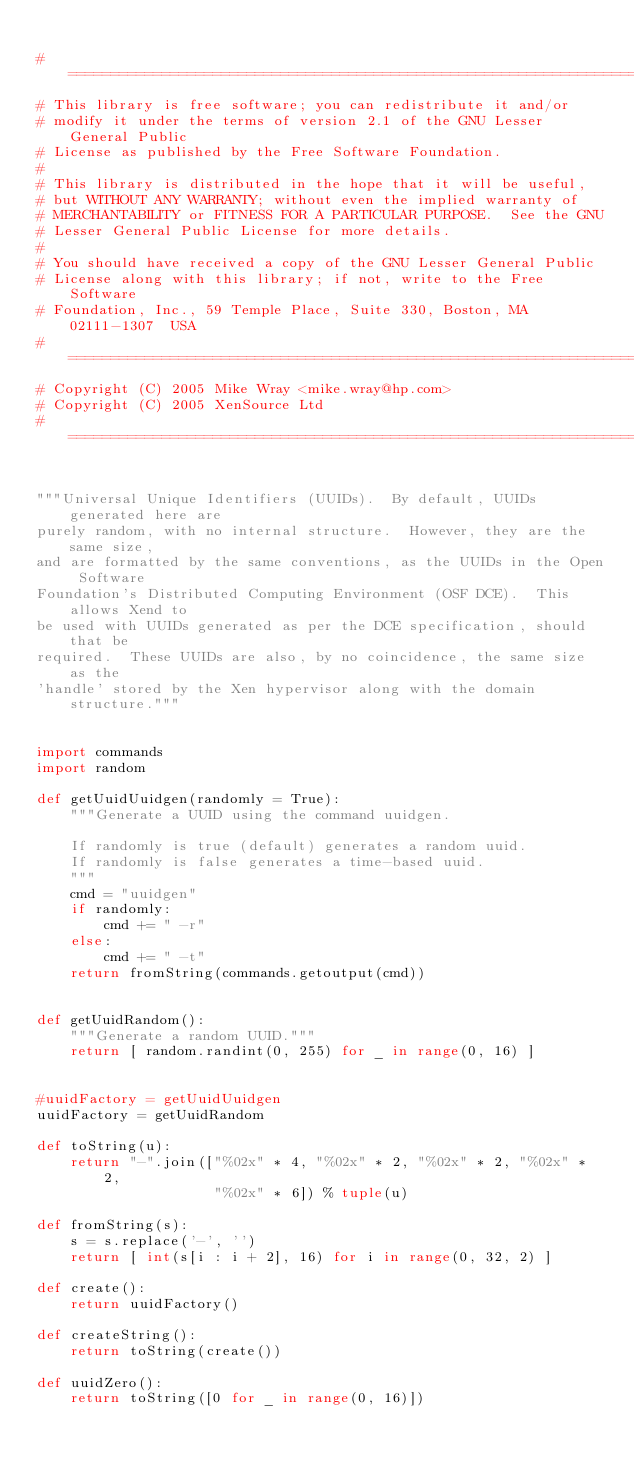<code> <loc_0><loc_0><loc_500><loc_500><_Python_>
#============================================================================
# This library is free software; you can redistribute it and/or
# modify it under the terms of version 2.1 of the GNU Lesser General Public
# License as published by the Free Software Foundation.
#
# This library is distributed in the hope that it will be useful,
# but WITHOUT ANY WARRANTY; without even the implied warranty of
# MERCHANTABILITY or FITNESS FOR A PARTICULAR PURPOSE.  See the GNU
# Lesser General Public License for more details.
#
# You should have received a copy of the GNU Lesser General Public
# License along with this library; if not, write to the Free Software
# Foundation, Inc., 59 Temple Place, Suite 330, Boston, MA  02111-1307  USA
#============================================================================
# Copyright (C) 2005 Mike Wray <mike.wray@hp.com>
# Copyright (C) 2005 XenSource Ltd
#============================================================================


"""Universal Unique Identifiers (UUIDs).  By default, UUIDs generated here are
purely random, with no internal structure.  However, they are the same size,
and are formatted by the same conventions, as the UUIDs in the Open Software
Foundation's Distributed Computing Environment (OSF DCE).  This allows Xend to
be used with UUIDs generated as per the DCE specification, should that be
required.  These UUIDs are also, by no coincidence, the same size as the
'handle' stored by the Xen hypervisor along with the domain structure."""


import commands
import random

def getUuidUuidgen(randomly = True):
    """Generate a UUID using the command uuidgen.

    If randomly is true (default) generates a random uuid.
    If randomly is false generates a time-based uuid.
    """
    cmd = "uuidgen"
    if randomly:
        cmd += " -r"
    else:
        cmd += " -t"
    return fromString(commands.getoutput(cmd))


def getUuidRandom():
    """Generate a random UUID."""
    return [ random.randint(0, 255) for _ in range(0, 16) ]


#uuidFactory = getUuidUuidgen
uuidFactory = getUuidRandom

def toString(u):
    return "-".join(["%02x" * 4, "%02x" * 2, "%02x" * 2, "%02x" * 2,
                     "%02x" * 6]) % tuple(u)

def fromString(s):
    s = s.replace('-', '')
    return [ int(s[i : i + 2], 16) for i in range(0, 32, 2) ]

def create():
    return uuidFactory()

def createString():
    return toString(create())

def uuidZero():
    return toString([0 for _ in range(0, 16)])
</code> 